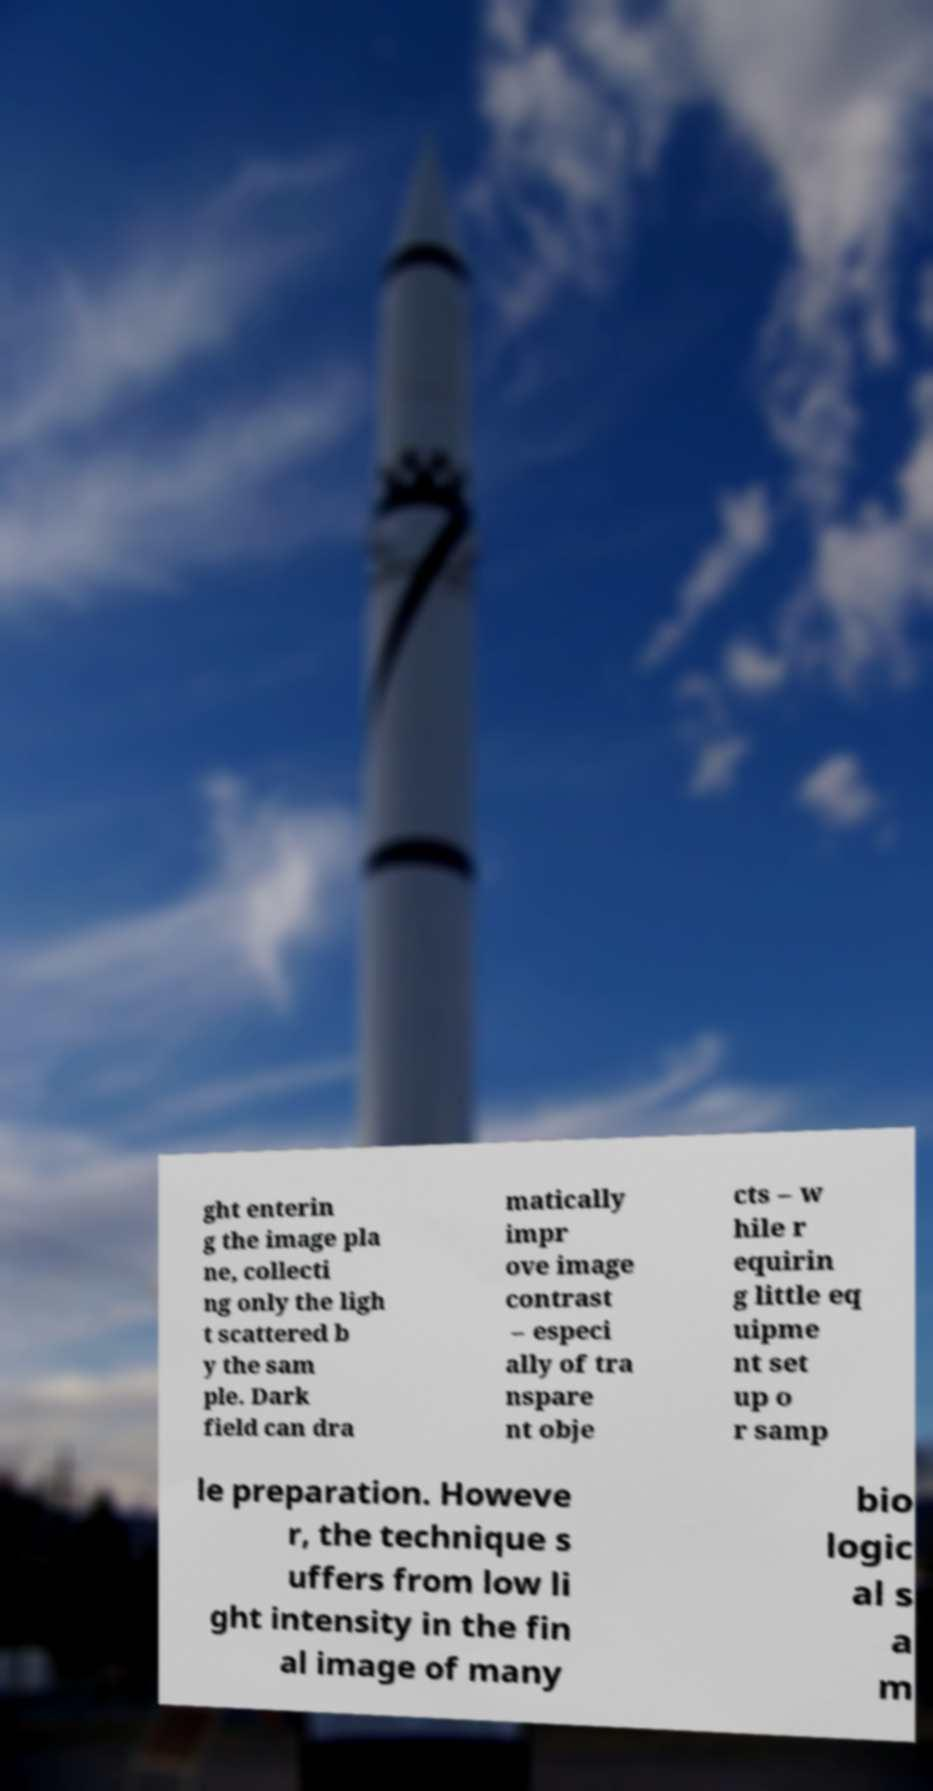What messages or text are displayed in this image? I need them in a readable, typed format. ght enterin g the image pla ne, collecti ng only the ligh t scattered b y the sam ple. Dark field can dra matically impr ove image contrast – especi ally of tra nspare nt obje cts – w hile r equirin g little eq uipme nt set up o r samp le preparation. Howeve r, the technique s uffers from low li ght intensity in the fin al image of many bio logic al s a m 